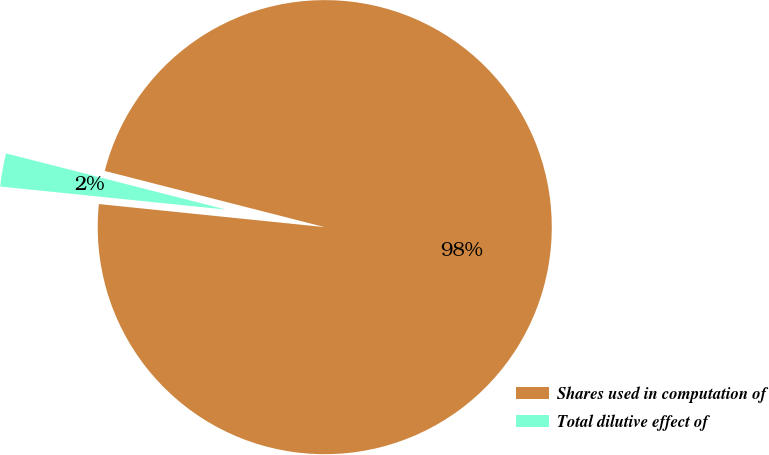<chart> <loc_0><loc_0><loc_500><loc_500><pie_chart><fcel>Shares used in computation of<fcel>Total dilutive effect of<nl><fcel>97.64%<fcel>2.36%<nl></chart> 